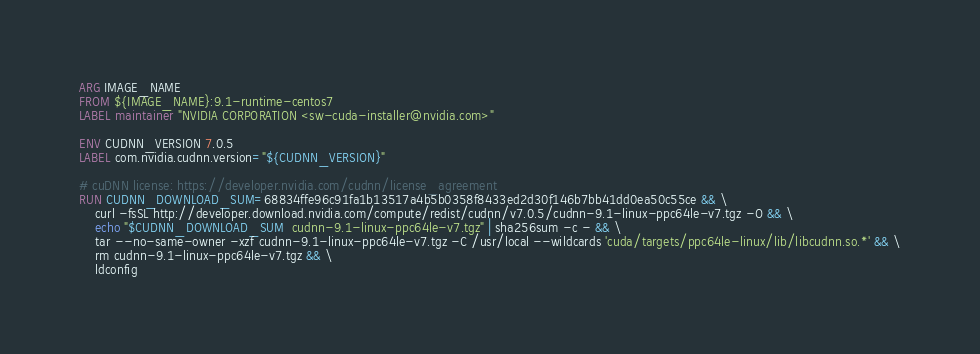Convert code to text. <code><loc_0><loc_0><loc_500><loc_500><_Dockerfile_>ARG IMAGE_NAME
FROM ${IMAGE_NAME}:9.1-runtime-centos7
LABEL maintainer "NVIDIA CORPORATION <sw-cuda-installer@nvidia.com>"

ENV CUDNN_VERSION 7.0.5
LABEL com.nvidia.cudnn.version="${CUDNN_VERSION}"

# cuDNN license: https://developer.nvidia.com/cudnn/license_agreement
RUN CUDNN_DOWNLOAD_SUM=68834ffe96c91fa1b13517a4b5b0358f8433ed2d30f146b7bb41dd0ea50c55ce && \
    curl -fsSL http://developer.download.nvidia.com/compute/redist/cudnn/v7.0.5/cudnn-9.1-linux-ppc64le-v7.tgz -O && \
    echo "$CUDNN_DOWNLOAD_SUM  cudnn-9.1-linux-ppc64le-v7.tgz" | sha256sum -c - && \
    tar --no-same-owner -xzf cudnn-9.1-linux-ppc64le-v7.tgz -C /usr/local --wildcards 'cuda/targets/ppc64le-linux/lib/libcudnn.so.*' && \
    rm cudnn-9.1-linux-ppc64le-v7.tgz && \
    ldconfig
</code> 